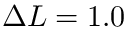Convert formula to latex. <formula><loc_0><loc_0><loc_500><loc_500>\Delta L = 1 . 0</formula> 